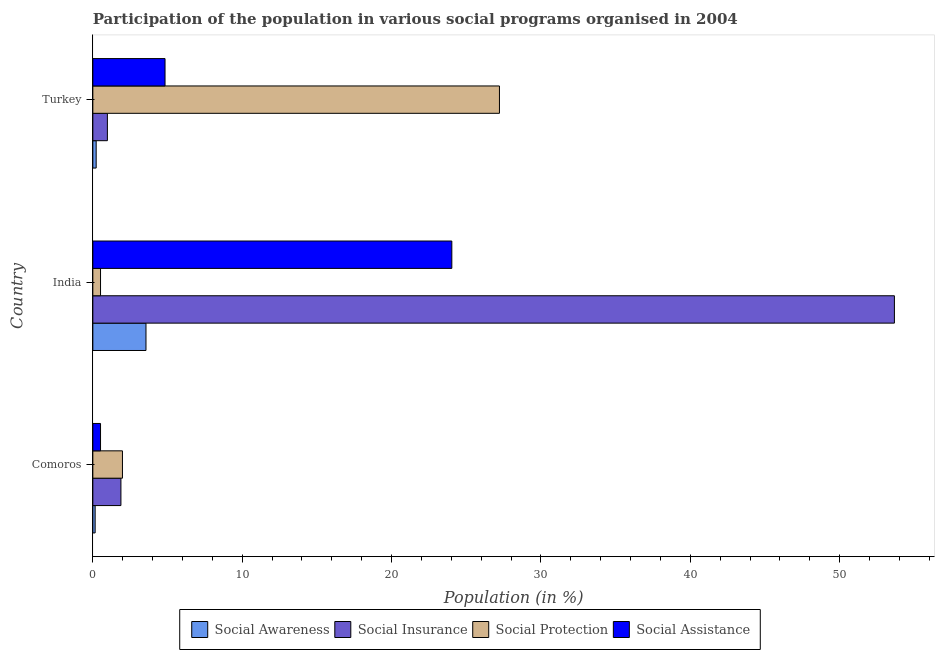How many groups of bars are there?
Ensure brevity in your answer.  3. Are the number of bars per tick equal to the number of legend labels?
Give a very brief answer. Yes. How many bars are there on the 3rd tick from the top?
Your answer should be compact. 4. What is the label of the 2nd group of bars from the top?
Offer a terse response. India. In how many cases, is the number of bars for a given country not equal to the number of legend labels?
Provide a succinct answer. 0. What is the participation of population in social assistance programs in Turkey?
Provide a short and direct response. 4.83. Across all countries, what is the maximum participation of population in social insurance programs?
Give a very brief answer. 53.66. Across all countries, what is the minimum participation of population in social protection programs?
Your answer should be very brief. 0.51. In which country was the participation of population in social awareness programs maximum?
Offer a terse response. India. What is the total participation of population in social assistance programs in the graph?
Give a very brief answer. 29.38. What is the difference between the participation of population in social protection programs in India and that in Turkey?
Keep it short and to the point. -26.71. What is the difference between the participation of population in social insurance programs in Comoros and the participation of population in social protection programs in India?
Offer a terse response. 1.37. What is the average participation of population in social assistance programs per country?
Ensure brevity in your answer.  9.79. What is the difference between the participation of population in social assistance programs and participation of population in social protection programs in Comoros?
Provide a short and direct response. -1.47. What is the ratio of the participation of population in social insurance programs in Comoros to that in India?
Provide a succinct answer. 0.04. Is the difference between the participation of population in social insurance programs in Comoros and India greater than the difference between the participation of population in social awareness programs in Comoros and India?
Offer a very short reply. No. What is the difference between the highest and the second highest participation of population in social assistance programs?
Give a very brief answer. 19.2. What is the difference between the highest and the lowest participation of population in social protection programs?
Give a very brief answer. 26.71. Is the sum of the participation of population in social protection programs in India and Turkey greater than the maximum participation of population in social awareness programs across all countries?
Offer a very short reply. Yes. What does the 2nd bar from the top in Turkey represents?
Your answer should be compact. Social Protection. What does the 3rd bar from the bottom in Turkey represents?
Give a very brief answer. Social Protection. Are all the bars in the graph horizontal?
Provide a succinct answer. Yes. How many countries are there in the graph?
Keep it short and to the point. 3. What is the title of the graph?
Give a very brief answer. Participation of the population in various social programs organised in 2004. What is the label or title of the X-axis?
Provide a short and direct response. Population (in %). What is the label or title of the Y-axis?
Your response must be concise. Country. What is the Population (in %) in Social Awareness in Comoros?
Your answer should be compact. 0.15. What is the Population (in %) in Social Insurance in Comoros?
Make the answer very short. 1.88. What is the Population (in %) in Social Protection in Comoros?
Your answer should be compact. 1.98. What is the Population (in %) in Social Assistance in Comoros?
Keep it short and to the point. 0.51. What is the Population (in %) in Social Awareness in India?
Make the answer very short. 3.56. What is the Population (in %) of Social Insurance in India?
Your answer should be compact. 53.66. What is the Population (in %) of Social Protection in India?
Offer a terse response. 0.51. What is the Population (in %) in Social Assistance in India?
Provide a succinct answer. 24.03. What is the Population (in %) of Social Awareness in Turkey?
Give a very brief answer. 0.22. What is the Population (in %) of Social Insurance in Turkey?
Your answer should be very brief. 0.97. What is the Population (in %) in Social Protection in Turkey?
Offer a very short reply. 27.22. What is the Population (in %) in Social Assistance in Turkey?
Ensure brevity in your answer.  4.83. Across all countries, what is the maximum Population (in %) of Social Awareness?
Your answer should be compact. 3.56. Across all countries, what is the maximum Population (in %) in Social Insurance?
Your answer should be compact. 53.66. Across all countries, what is the maximum Population (in %) of Social Protection?
Offer a terse response. 27.22. Across all countries, what is the maximum Population (in %) in Social Assistance?
Your answer should be compact. 24.03. Across all countries, what is the minimum Population (in %) in Social Awareness?
Give a very brief answer. 0.15. Across all countries, what is the minimum Population (in %) in Social Insurance?
Your response must be concise. 0.97. Across all countries, what is the minimum Population (in %) of Social Protection?
Give a very brief answer. 0.51. Across all countries, what is the minimum Population (in %) in Social Assistance?
Ensure brevity in your answer.  0.51. What is the total Population (in %) in Social Awareness in the graph?
Make the answer very short. 3.93. What is the total Population (in %) in Social Insurance in the graph?
Keep it short and to the point. 56.52. What is the total Population (in %) in Social Protection in the graph?
Provide a short and direct response. 29.72. What is the total Population (in %) of Social Assistance in the graph?
Offer a very short reply. 29.38. What is the difference between the Population (in %) in Social Awareness in Comoros and that in India?
Provide a short and direct response. -3.4. What is the difference between the Population (in %) in Social Insurance in Comoros and that in India?
Make the answer very short. -51.78. What is the difference between the Population (in %) in Social Protection in Comoros and that in India?
Provide a succinct answer. 1.47. What is the difference between the Population (in %) of Social Assistance in Comoros and that in India?
Offer a very short reply. -23.52. What is the difference between the Population (in %) of Social Awareness in Comoros and that in Turkey?
Your response must be concise. -0.07. What is the difference between the Population (in %) of Social Insurance in Comoros and that in Turkey?
Keep it short and to the point. 0.91. What is the difference between the Population (in %) of Social Protection in Comoros and that in Turkey?
Keep it short and to the point. -25.24. What is the difference between the Population (in %) of Social Assistance in Comoros and that in Turkey?
Provide a short and direct response. -4.32. What is the difference between the Population (in %) of Social Awareness in India and that in Turkey?
Offer a very short reply. 3.33. What is the difference between the Population (in %) of Social Insurance in India and that in Turkey?
Your answer should be very brief. 52.69. What is the difference between the Population (in %) in Social Protection in India and that in Turkey?
Offer a terse response. -26.71. What is the difference between the Population (in %) in Social Assistance in India and that in Turkey?
Your answer should be compact. 19.2. What is the difference between the Population (in %) of Social Awareness in Comoros and the Population (in %) of Social Insurance in India?
Your response must be concise. -53.51. What is the difference between the Population (in %) in Social Awareness in Comoros and the Population (in %) in Social Protection in India?
Keep it short and to the point. -0.36. What is the difference between the Population (in %) of Social Awareness in Comoros and the Population (in %) of Social Assistance in India?
Your response must be concise. -23.88. What is the difference between the Population (in %) of Social Insurance in Comoros and the Population (in %) of Social Protection in India?
Make the answer very short. 1.37. What is the difference between the Population (in %) in Social Insurance in Comoros and the Population (in %) in Social Assistance in India?
Provide a short and direct response. -22.15. What is the difference between the Population (in %) of Social Protection in Comoros and the Population (in %) of Social Assistance in India?
Give a very brief answer. -22.05. What is the difference between the Population (in %) in Social Awareness in Comoros and the Population (in %) in Social Insurance in Turkey?
Your answer should be very brief. -0.82. What is the difference between the Population (in %) of Social Awareness in Comoros and the Population (in %) of Social Protection in Turkey?
Provide a short and direct response. -27.07. What is the difference between the Population (in %) of Social Awareness in Comoros and the Population (in %) of Social Assistance in Turkey?
Provide a short and direct response. -4.68. What is the difference between the Population (in %) of Social Insurance in Comoros and the Population (in %) of Social Protection in Turkey?
Your response must be concise. -25.34. What is the difference between the Population (in %) of Social Insurance in Comoros and the Population (in %) of Social Assistance in Turkey?
Give a very brief answer. -2.95. What is the difference between the Population (in %) of Social Protection in Comoros and the Population (in %) of Social Assistance in Turkey?
Provide a short and direct response. -2.85. What is the difference between the Population (in %) of Social Awareness in India and the Population (in %) of Social Insurance in Turkey?
Your answer should be very brief. 2.58. What is the difference between the Population (in %) in Social Awareness in India and the Population (in %) in Social Protection in Turkey?
Give a very brief answer. -23.66. What is the difference between the Population (in %) in Social Awareness in India and the Population (in %) in Social Assistance in Turkey?
Keep it short and to the point. -1.28. What is the difference between the Population (in %) in Social Insurance in India and the Population (in %) in Social Protection in Turkey?
Provide a succinct answer. 26.44. What is the difference between the Population (in %) in Social Insurance in India and the Population (in %) in Social Assistance in Turkey?
Offer a terse response. 48.83. What is the difference between the Population (in %) in Social Protection in India and the Population (in %) in Social Assistance in Turkey?
Ensure brevity in your answer.  -4.32. What is the average Population (in %) in Social Awareness per country?
Ensure brevity in your answer.  1.31. What is the average Population (in %) of Social Insurance per country?
Provide a short and direct response. 18.84. What is the average Population (in %) in Social Protection per country?
Provide a short and direct response. 9.91. What is the average Population (in %) in Social Assistance per country?
Offer a very short reply. 9.79. What is the difference between the Population (in %) of Social Awareness and Population (in %) of Social Insurance in Comoros?
Your answer should be compact. -1.73. What is the difference between the Population (in %) in Social Awareness and Population (in %) in Social Protection in Comoros?
Offer a very short reply. -1.83. What is the difference between the Population (in %) of Social Awareness and Population (in %) of Social Assistance in Comoros?
Offer a terse response. -0.36. What is the difference between the Population (in %) in Social Insurance and Population (in %) in Social Protection in Comoros?
Ensure brevity in your answer.  -0.1. What is the difference between the Population (in %) in Social Insurance and Population (in %) in Social Assistance in Comoros?
Provide a succinct answer. 1.37. What is the difference between the Population (in %) in Social Protection and Population (in %) in Social Assistance in Comoros?
Your answer should be compact. 1.47. What is the difference between the Population (in %) of Social Awareness and Population (in %) of Social Insurance in India?
Offer a very short reply. -50.1. What is the difference between the Population (in %) in Social Awareness and Population (in %) in Social Protection in India?
Offer a very short reply. 3.04. What is the difference between the Population (in %) of Social Awareness and Population (in %) of Social Assistance in India?
Provide a succinct answer. -20.47. What is the difference between the Population (in %) of Social Insurance and Population (in %) of Social Protection in India?
Keep it short and to the point. 53.15. What is the difference between the Population (in %) of Social Insurance and Population (in %) of Social Assistance in India?
Your answer should be very brief. 29.63. What is the difference between the Population (in %) in Social Protection and Population (in %) in Social Assistance in India?
Offer a very short reply. -23.52. What is the difference between the Population (in %) in Social Awareness and Population (in %) in Social Insurance in Turkey?
Ensure brevity in your answer.  -0.75. What is the difference between the Population (in %) of Social Awareness and Population (in %) of Social Protection in Turkey?
Make the answer very short. -27. What is the difference between the Population (in %) of Social Awareness and Population (in %) of Social Assistance in Turkey?
Your answer should be compact. -4.61. What is the difference between the Population (in %) in Social Insurance and Population (in %) in Social Protection in Turkey?
Provide a short and direct response. -26.25. What is the difference between the Population (in %) of Social Insurance and Population (in %) of Social Assistance in Turkey?
Ensure brevity in your answer.  -3.86. What is the difference between the Population (in %) in Social Protection and Population (in %) in Social Assistance in Turkey?
Offer a terse response. 22.39. What is the ratio of the Population (in %) in Social Awareness in Comoros to that in India?
Your response must be concise. 0.04. What is the ratio of the Population (in %) of Social Insurance in Comoros to that in India?
Your response must be concise. 0.04. What is the ratio of the Population (in %) in Social Protection in Comoros to that in India?
Provide a succinct answer. 3.85. What is the ratio of the Population (in %) in Social Assistance in Comoros to that in India?
Your answer should be compact. 0.02. What is the ratio of the Population (in %) in Social Awareness in Comoros to that in Turkey?
Ensure brevity in your answer.  0.69. What is the ratio of the Population (in %) in Social Insurance in Comoros to that in Turkey?
Ensure brevity in your answer.  1.93. What is the ratio of the Population (in %) of Social Protection in Comoros to that in Turkey?
Keep it short and to the point. 0.07. What is the ratio of the Population (in %) of Social Assistance in Comoros to that in Turkey?
Offer a very short reply. 0.11. What is the ratio of the Population (in %) of Social Awareness in India to that in Turkey?
Offer a very short reply. 15.95. What is the ratio of the Population (in %) in Social Insurance in India to that in Turkey?
Offer a terse response. 55.09. What is the ratio of the Population (in %) in Social Protection in India to that in Turkey?
Your answer should be very brief. 0.02. What is the ratio of the Population (in %) in Social Assistance in India to that in Turkey?
Your answer should be compact. 4.97. What is the difference between the highest and the second highest Population (in %) of Social Awareness?
Provide a short and direct response. 3.33. What is the difference between the highest and the second highest Population (in %) of Social Insurance?
Keep it short and to the point. 51.78. What is the difference between the highest and the second highest Population (in %) of Social Protection?
Ensure brevity in your answer.  25.24. What is the difference between the highest and the second highest Population (in %) in Social Assistance?
Your answer should be very brief. 19.2. What is the difference between the highest and the lowest Population (in %) of Social Awareness?
Your response must be concise. 3.4. What is the difference between the highest and the lowest Population (in %) in Social Insurance?
Provide a short and direct response. 52.69. What is the difference between the highest and the lowest Population (in %) of Social Protection?
Your answer should be very brief. 26.71. What is the difference between the highest and the lowest Population (in %) in Social Assistance?
Provide a short and direct response. 23.52. 